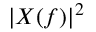Convert formula to latex. <formula><loc_0><loc_0><loc_500><loc_500>| X ( f ) | ^ { 2 }</formula> 